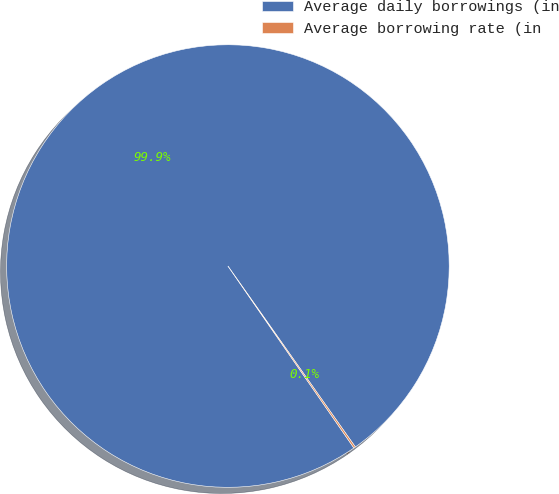Convert chart to OTSL. <chart><loc_0><loc_0><loc_500><loc_500><pie_chart><fcel>Average daily borrowings (in<fcel>Average borrowing rate (in<nl><fcel>99.87%<fcel>0.13%<nl></chart> 